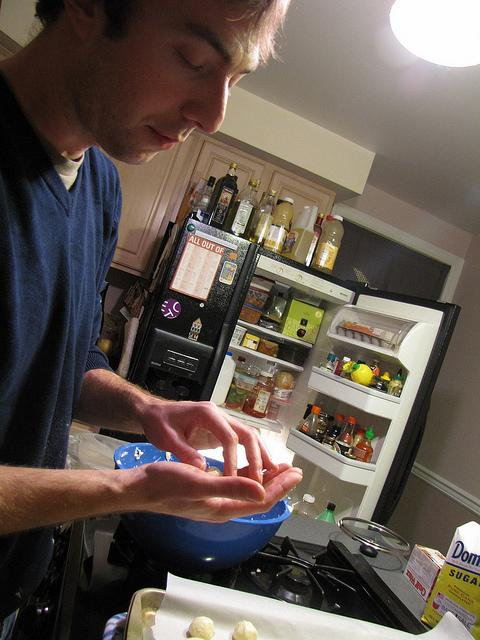What type of kitchen is shown?

Choices:
A) commercial
B) hospital
C) food truck
D) residential residential 